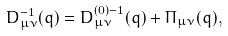Convert formula to latex. <formula><loc_0><loc_0><loc_500><loc_500>D _ { \mu \nu } ^ { - 1 } ( q ) = D _ { \mu \nu } ^ { ( 0 ) - 1 } ( q ) + \Pi _ { \mu \nu } ( q ) ,</formula> 